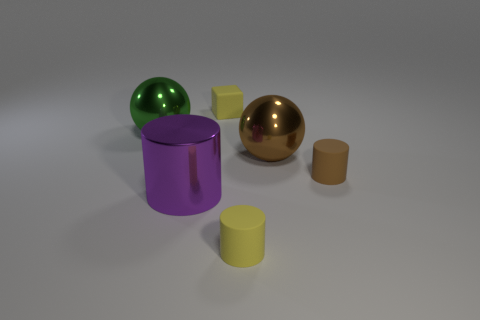How many small things are rubber objects or green spheres?
Your answer should be compact. 3. Are there an equal number of big things to the right of the brown ball and small rubber objects in front of the brown cylinder?
Give a very brief answer. No. What number of other blocks are the same size as the yellow block?
Give a very brief answer. 0. What number of green objects are cubes or tiny cylinders?
Your answer should be compact. 0. Is the number of rubber things in front of the tiny brown matte thing the same as the number of red shiny blocks?
Give a very brief answer. No. What size is the thing to the left of the big purple metal cylinder?
Give a very brief answer. Large. How many other brown rubber objects have the same shape as the large brown thing?
Your answer should be compact. 0. The tiny thing that is to the left of the brown rubber cylinder and in front of the green object is made of what material?
Your response must be concise. Rubber. Does the brown ball have the same material as the green thing?
Give a very brief answer. Yes. What number of metal objects are there?
Ensure brevity in your answer.  3. 